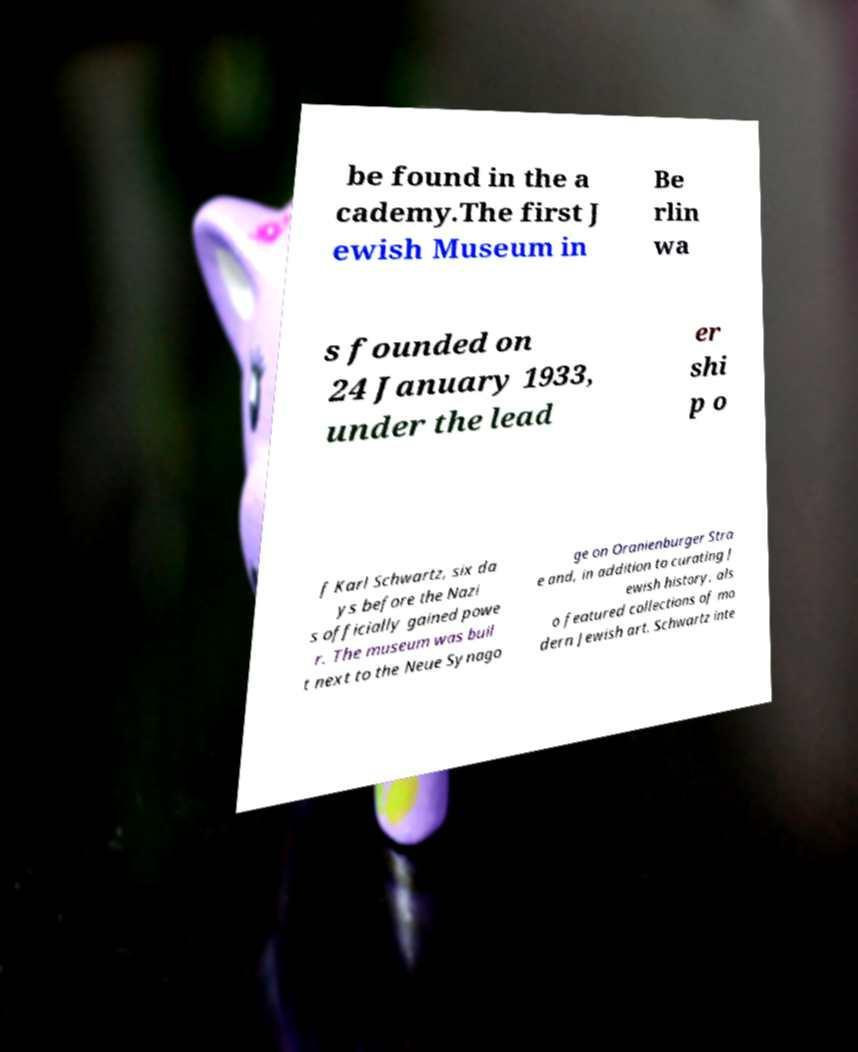For documentation purposes, I need the text within this image transcribed. Could you provide that? be found in the a cademy.The first J ewish Museum in Be rlin wa s founded on 24 January 1933, under the lead er shi p o f Karl Schwartz, six da ys before the Nazi s officially gained powe r. The museum was buil t next to the Neue Synago ge on Oranienburger Stra e and, in addition to curating J ewish history, als o featured collections of mo dern Jewish art. Schwartz inte 